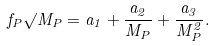Convert formula to latex. <formula><loc_0><loc_0><loc_500><loc_500>f _ { P } \surd M _ { P } = a _ { 1 } + \frac { a _ { 2 } } { M _ { P } } + \frac { a _ { 3 } } { M _ { P } ^ { 2 } } .</formula> 